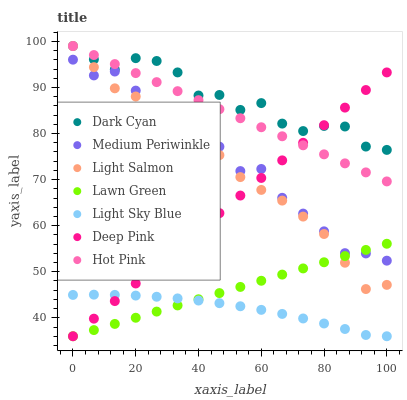Does Light Sky Blue have the minimum area under the curve?
Answer yes or no. Yes. Does Dark Cyan have the maximum area under the curve?
Answer yes or no. Yes. Does Light Salmon have the minimum area under the curve?
Answer yes or no. No. Does Light Salmon have the maximum area under the curve?
Answer yes or no. No. Is Lawn Green the smoothest?
Answer yes or no. Yes. Is Dark Cyan the roughest?
Answer yes or no. Yes. Is Light Salmon the smoothest?
Answer yes or no. No. Is Light Salmon the roughest?
Answer yes or no. No. Does Lawn Green have the lowest value?
Answer yes or no. Yes. Does Light Salmon have the lowest value?
Answer yes or no. No. Does Dark Cyan have the highest value?
Answer yes or no. Yes. Does Deep Pink have the highest value?
Answer yes or no. No. Is Lawn Green less than Hot Pink?
Answer yes or no. Yes. Is Hot Pink greater than Light Sky Blue?
Answer yes or no. Yes. Does Light Salmon intersect Dark Cyan?
Answer yes or no. Yes. Is Light Salmon less than Dark Cyan?
Answer yes or no. No. Is Light Salmon greater than Dark Cyan?
Answer yes or no. No. Does Lawn Green intersect Hot Pink?
Answer yes or no. No. 